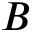<formula> <loc_0><loc_0><loc_500><loc_500>B</formula> 